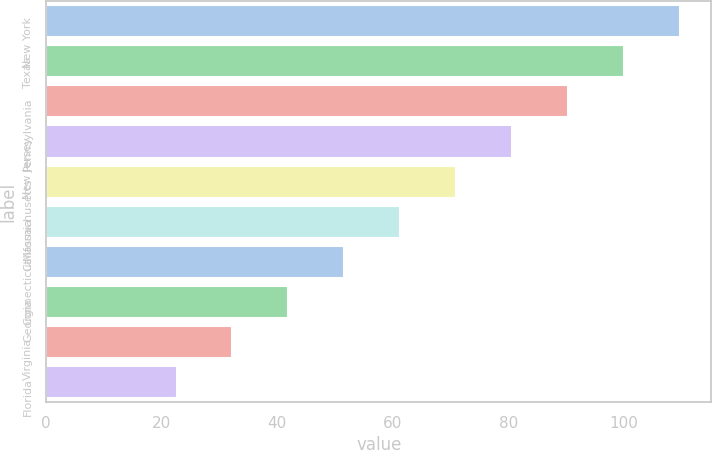Convert chart. <chart><loc_0><loc_0><loc_500><loc_500><bar_chart><fcel>New York<fcel>Texas<fcel>Pennsylvania<fcel>New Jersey<fcel>Massachusetts<fcel>California<fcel>Connecticut<fcel>Georgia<fcel>Virginia<fcel>Florida<nl><fcel>109.68<fcel>100<fcel>90.32<fcel>80.64<fcel>70.96<fcel>61.28<fcel>51.6<fcel>41.92<fcel>32.24<fcel>22.56<nl></chart> 